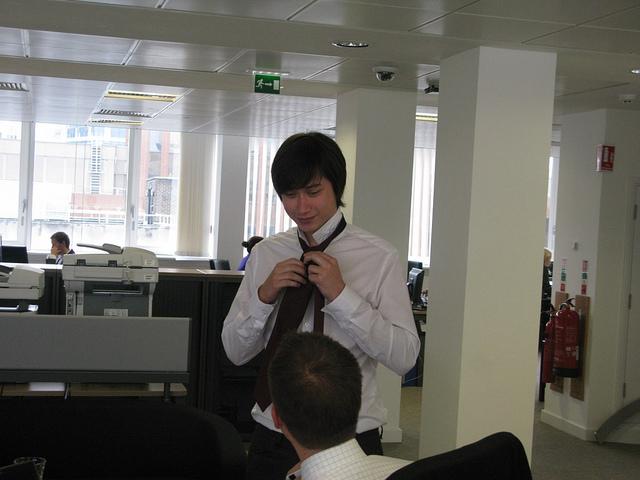Is there a fire extinguisher in this scene?
Answer briefly. Yes. Is the exit to the right of the photo?
Write a very short answer. Yes. Do you see a photocopier?
Give a very brief answer. Yes. 